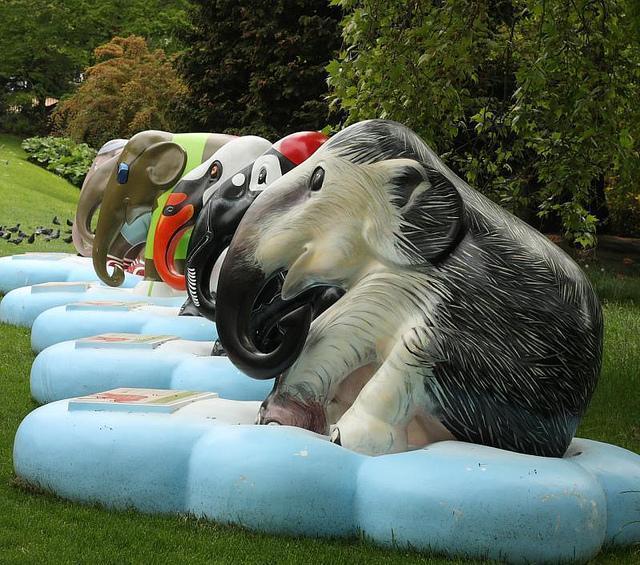How would these animals be described?
Indicate the correct choice and explain in the format: 'Answer: answer
Rationale: rationale.'
Options: Canine, human made, feline, bovine. Answer: human made.
Rationale: They have a shiny surface rather than the leathery skin that real animals have. 